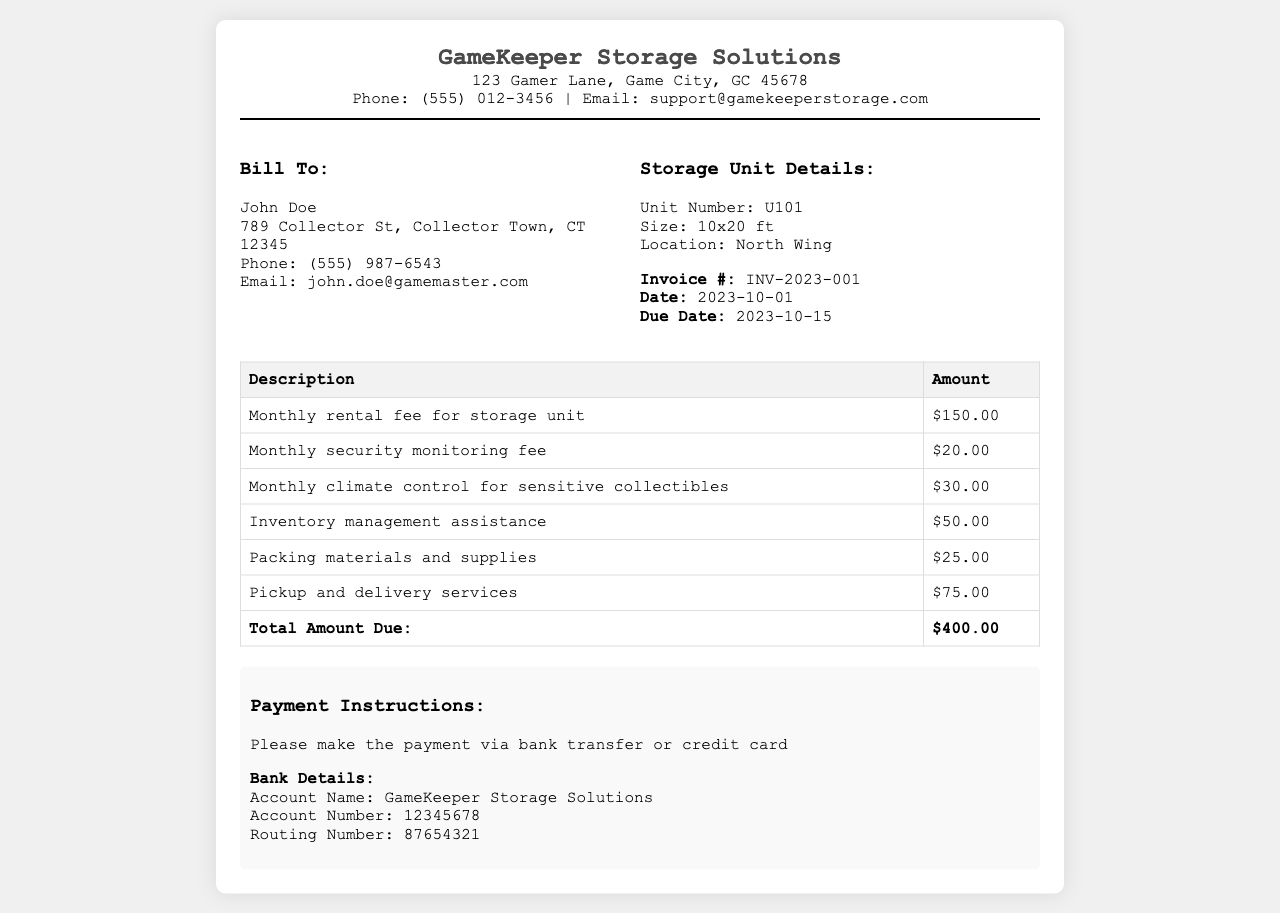What is the monthly rental fee for the storage unit? The monthly rental fee for the storage unit is listed in the document under the description of the charges.
Answer: $150.00 What is the due date for this invoice? The due date for the invoice is mentioned in the document with the other invoice details.
Answer: 2023-10-15 Who is the billing recipient for this invoice? The billing recipient is specified in the "Bill To" section of the document.
Answer: John Doe How much is the charge for packing materials and supplies? This charge is detailed in the table of costs under the description of services.
Answer: $25.00 What is the total amount due for this invoice? The total amount due is summarized at the bottom of the table.
Answer: $400.00 What services does the monthly security monitoring fee cover? This question requires reasoning; while not explicitly stated, it's common knowledge that this fee ensures the safety of items in the storage unit.
Answer: Security monitoring What other additional service is included besides storage rental? By reviewing the document, multiple additional services are listed beyond the storage rental.
Answer: Monthly security monitoring fee How many services are listed in total in the invoice? The document provides an itemized list of additional services included in the invoice table.
Answer: Six services What is the size of the storage unit rented? The size of the storage unit is mentioned in the "Storage Unit Details" section of the document.
Answer: 10x20 ft 